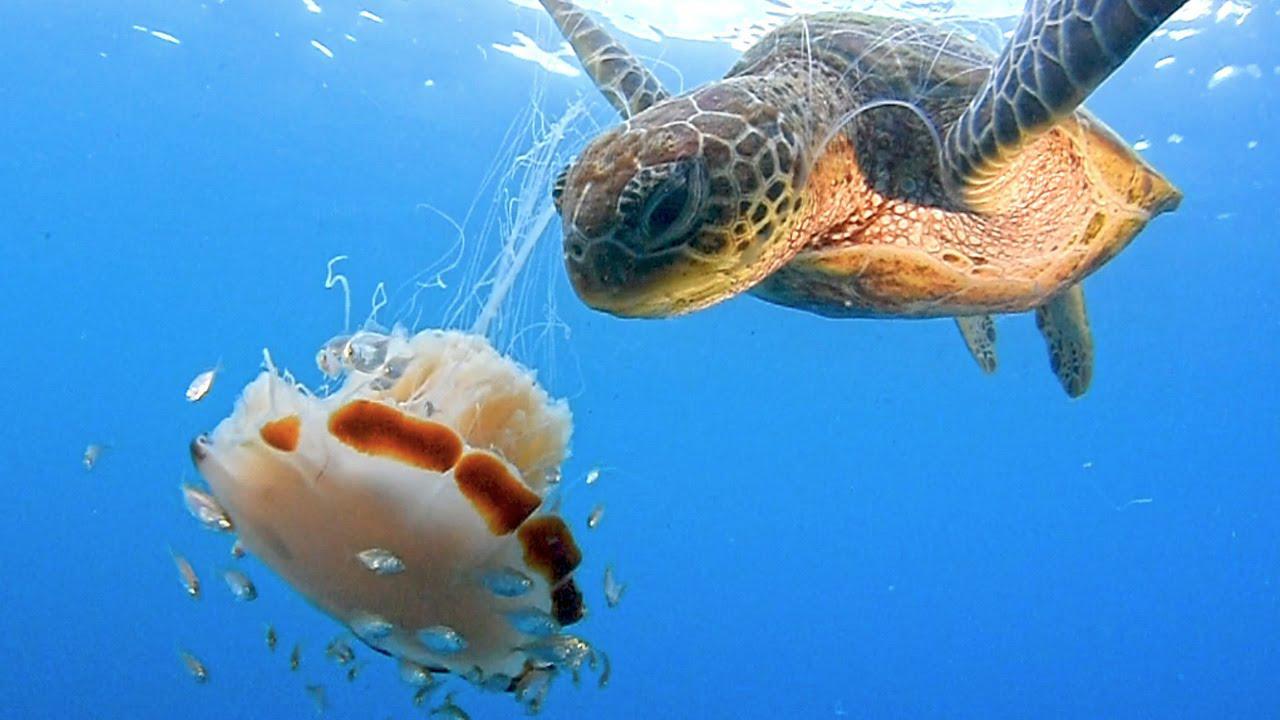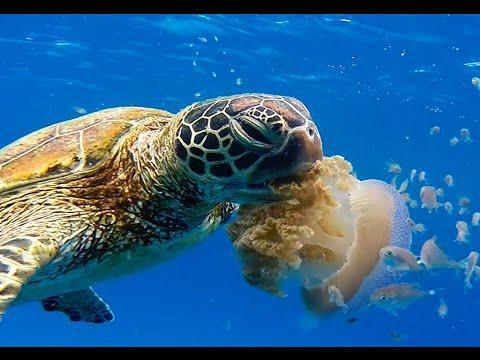The first image is the image on the left, the second image is the image on the right. Assess this claim about the two images: "A sea turtle with distinctly textured skin has its open mouth next to a purplish saucer-shaped jellyfish.". Correct or not? Answer yes or no. No. The first image is the image on the left, the second image is the image on the right. Assess this claim about the two images: "There is a sea turtle that is taking a bite at what appears to be a purple jellyfish.". Correct or not? Answer yes or no. No. 